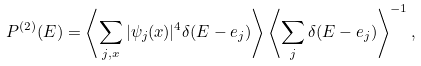<formula> <loc_0><loc_0><loc_500><loc_500>P ^ { ( 2 ) } ( E ) = \left \langle \sum _ { j , x } | \psi _ { j } ( x ) | ^ { 4 } \delta ( E - e _ { j } ) \right \rangle \left \langle \sum _ { j } \delta ( E - e _ { j } ) \right \rangle ^ { - 1 } ,</formula> 